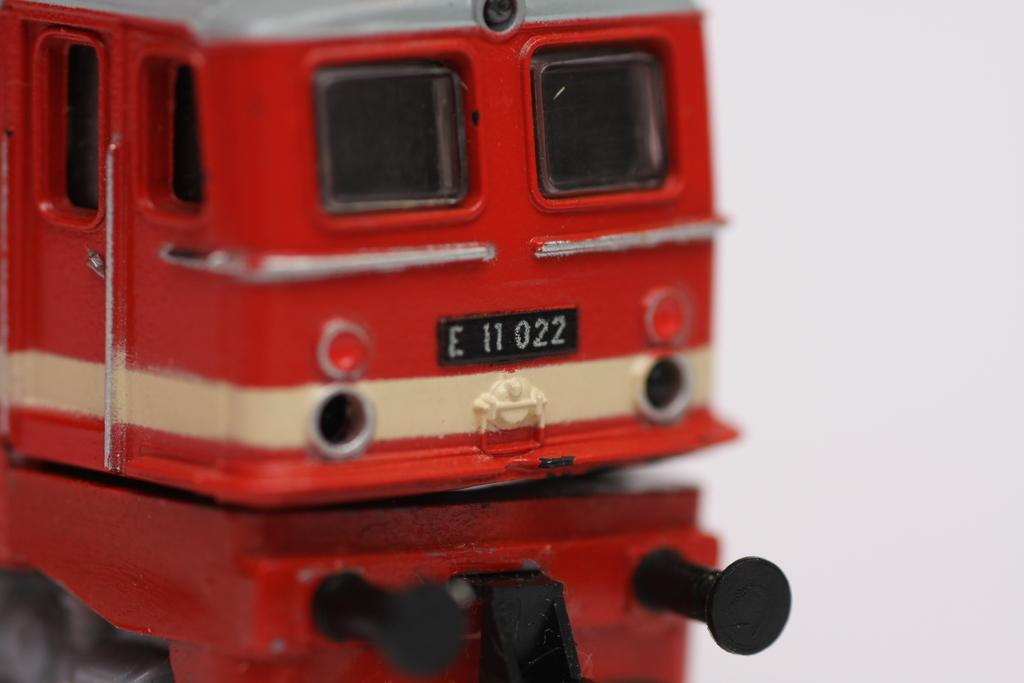<image>
Provide a brief description of the given image. A red toy train has a license with the number E 11 022. 